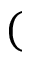Convert formula to latex. <formula><loc_0><loc_0><loc_500><loc_500>(</formula> 